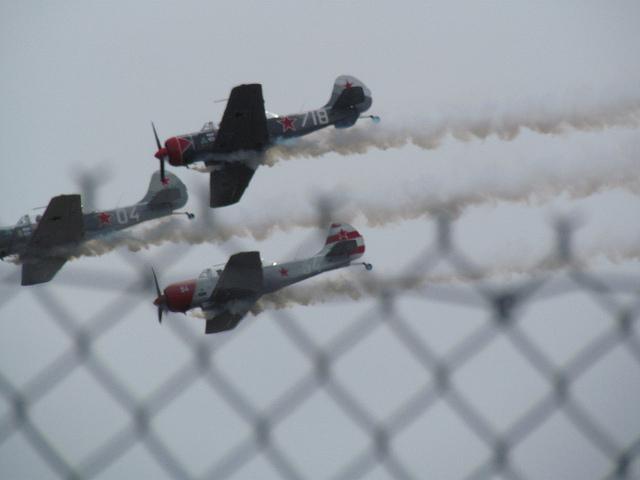How many planes are there?
Quick response, please. 3. Are they performing an air show?
Write a very short answer. Yes. What number is on the middle plane?
Give a very brief answer. 04. 